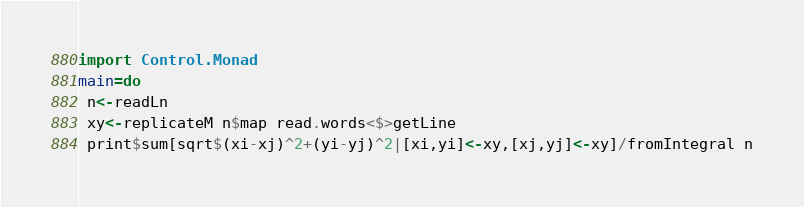Convert code to text. <code><loc_0><loc_0><loc_500><loc_500><_Haskell_>import Control.Monad
main=do
 n<-readLn
 xy<-replicateM n$map read.words<$>getLine
 print$sum[sqrt$(xi-xj)^2+(yi-yj)^2|[xi,yi]<-xy,[xj,yj]<-xy]/fromIntegral n</code> 